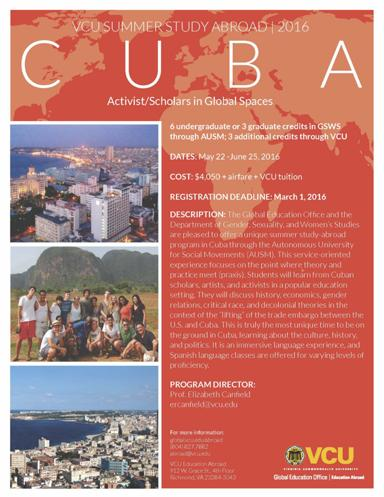What additional information can you provide about the collaboration with the Autonomous University for Social Movements? The collaboration with the Autonomous University for Social Movements (AUSM) is central to the study abroad program. AUSM is known for its dedication to social change education, providing students with unique insights into societal dynamics. This partnership allows students to engage directly with local activists and scholars, thereby deepening their understanding of global issues in a localized Cuban context. 